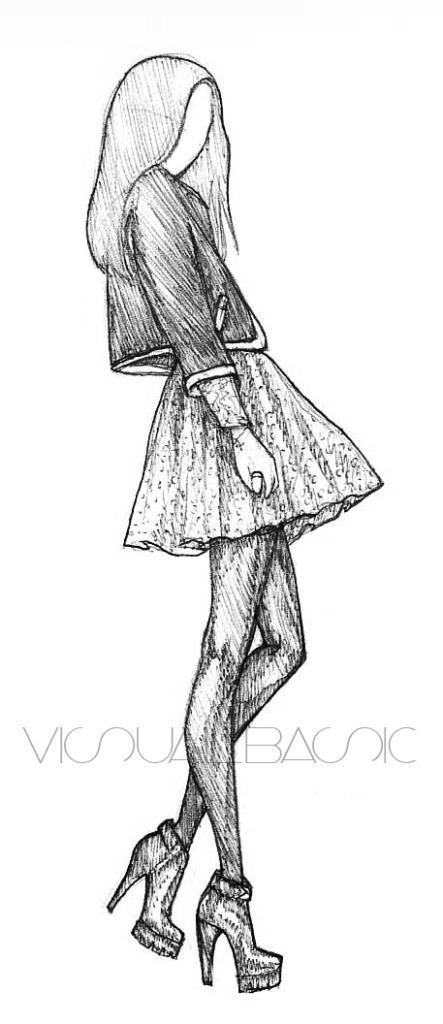Could you give a brief overview of what you see in this image? This picture is consists a sketch of a girl. 